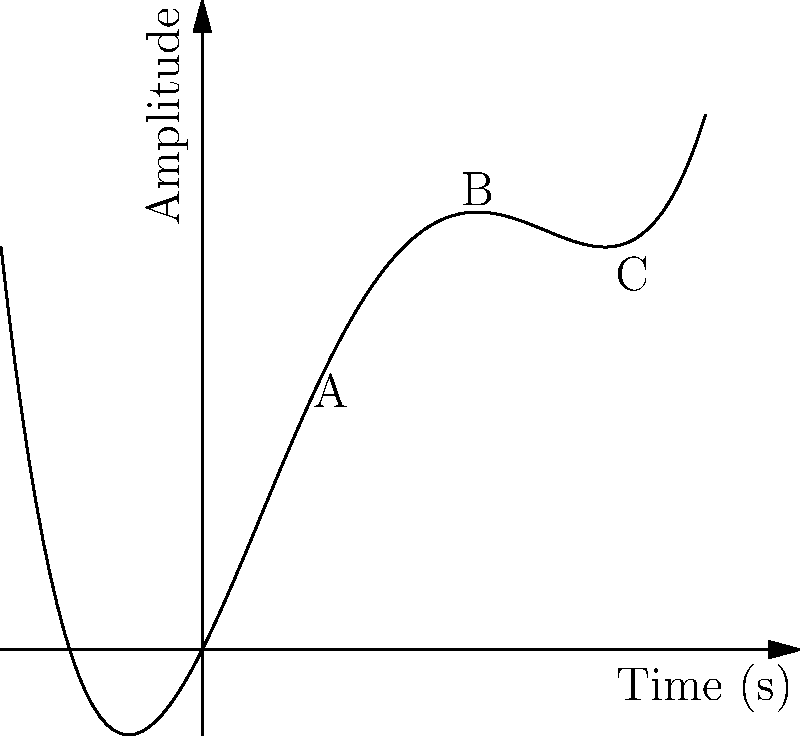The graph above represents the sound wave of a traditional Scottish bagpipe, modeled by a polynomial function. Which point on the graph (A, B, or C) corresponds to the highest pitch in the bagpipe's sound? To determine which point corresponds to the highest pitch in the bagpipe's sound, we need to consider the relationship between pitch and frequency in sound waves:

1. Pitch is directly related to frequency: higher frequency results in higher pitch.
2. In a graph of amplitude vs. time, frequency is represented by how close together the peaks (or troughs) are.
3. Higher frequency means peaks are closer together in time.
4. Closer peaks result in a steeper slope on the graph.

Analyzing the given points:

A: Located at a relatively gentle slope.
B: Located at the steepest part of the curve.
C: Located at a moderate slope, less steep than B.

Point B is where the graph has the steepest slope, indicating the closest peaks and thus the highest frequency. Therefore, point B corresponds to the highest pitch in the bagpipe's sound.
Answer: B 